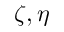Convert formula to latex. <formula><loc_0><loc_0><loc_500><loc_500>\zeta , \eta</formula> 